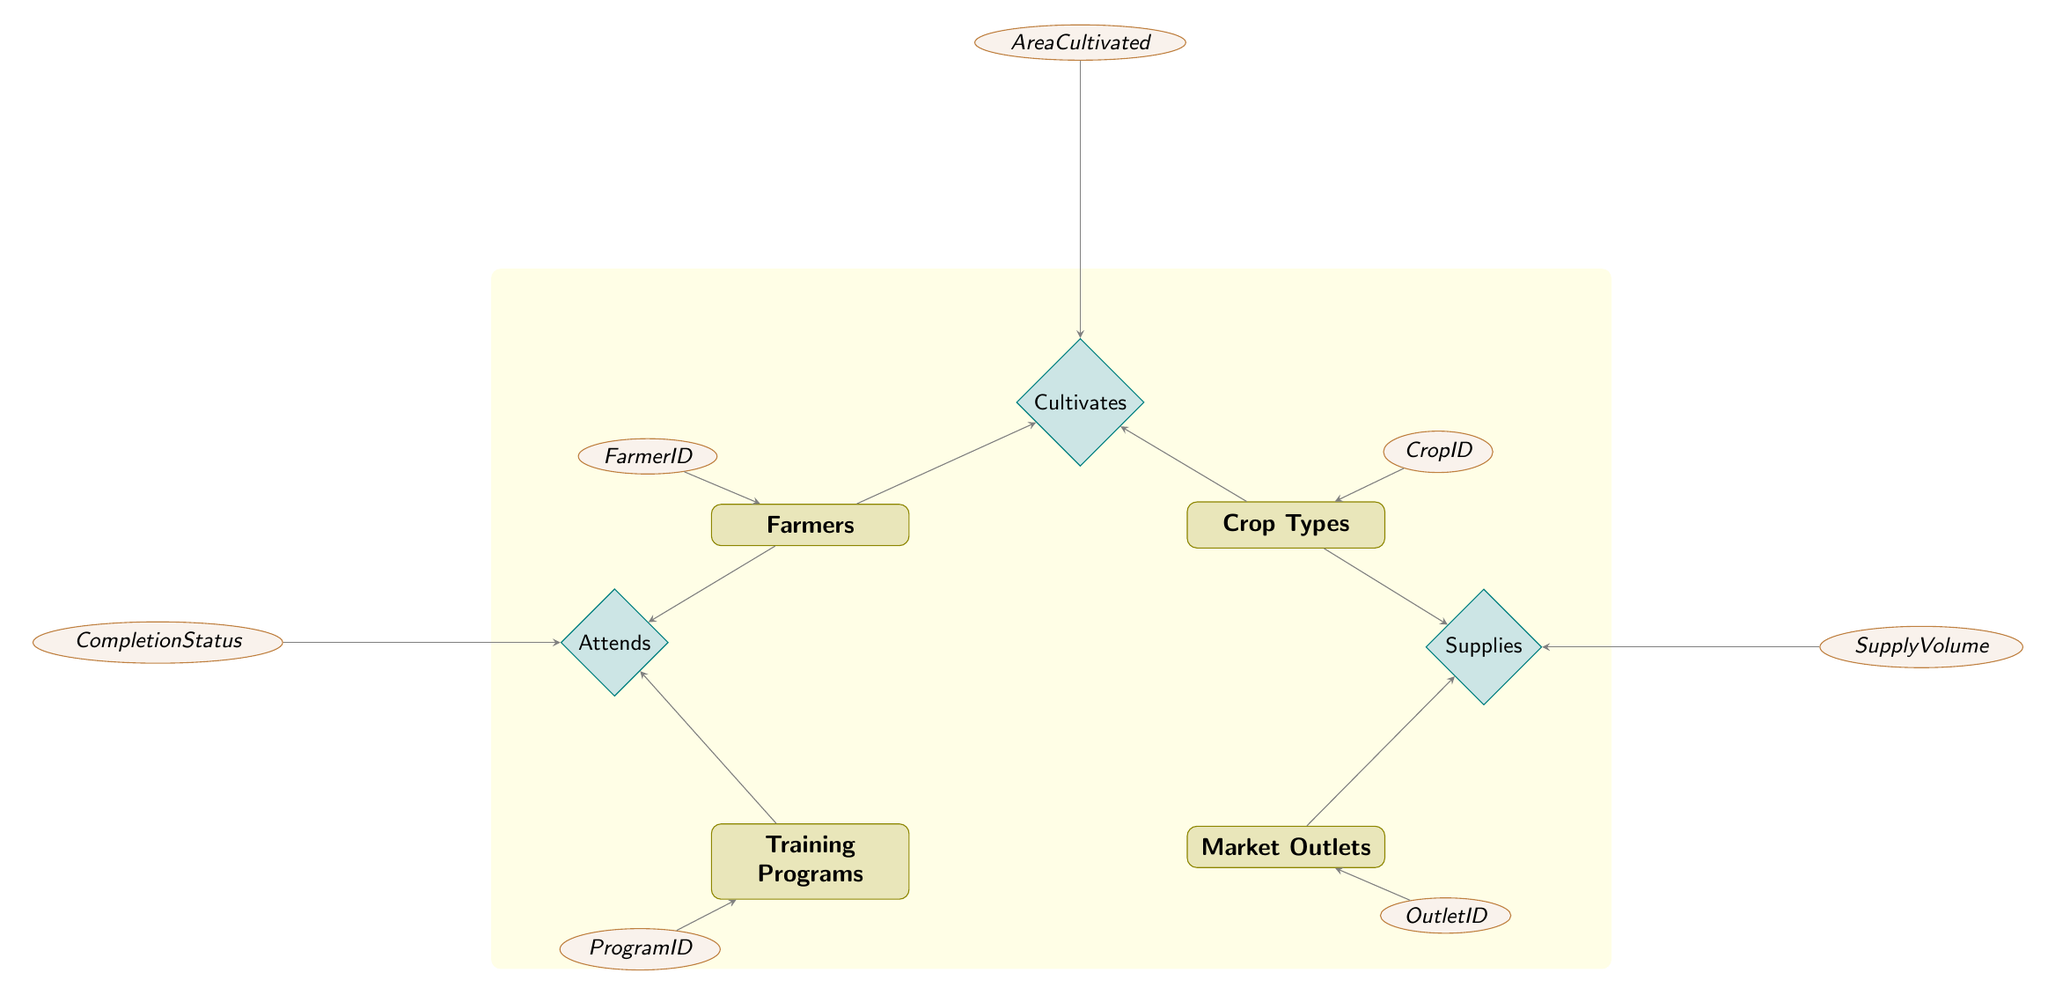What are the nodes in the diagram? The diagram contains four main entities: Farmers, Crop Types, Training Programs, and Market Outlets. Each of these entities is represented by a rectangular node.
Answer: Farmers, Crop Types, Training Programs, Market Outlets How many attributes does the Crop Types entity have? The Crop Types entity has three attributes listed: CropID, CropName, and Season. Counting these gives a total of three.
Answer: 3 What is the relationship type between Farmers and Crop Types? The relationship between Farmers and Crop Types is Many-to-Many, as indicated in the diagram's relationship representing the cultivates connection.
Answer: Many-to-Many What is the focus of the Training Programs? The Training Programs entity includes an attribute for Focus, indicating the main subject of the training, but this focus wasn't explicitly detailed in the example data given.
Answer: Focus Which attributes are associated with the relationship between Farmers and Training Programs? The relationship between Farmers and Training Programs has two attributes: CompletionStatus and Certification. This indicates the status and outcome of each farmer's participation in training programs.
Answer: CompletionStatus, Certification How many edges connect the Farmers entity to the Training Programs entity? There is one relationship line connecting Farmers to Training Programs through the Attends relationship. This indicates how farmers attend training programs.
Answer: 1 What is the common element among Market Outlets and Crop Types? Both Market Outlets and Crop Types are connected through a Many-to-Many relationship called Supplies, which indicates how different crop types supply market outlets.
Answer: Supplies What attribute represents how much a farmer cultivates? The attribute that represents how much a farmer cultivates is AreaCultivated, which is linked to the relationship between Farmers and Crop Types.
Answer: AreaCultivated How do Crop Types and Market Outlets relate to each other? Crop Types and Market Outlets are related through a Many-to-Many relationship called Supplies, which details how crop types can supply various market outlets and their parameters.
Answer: Supplies 